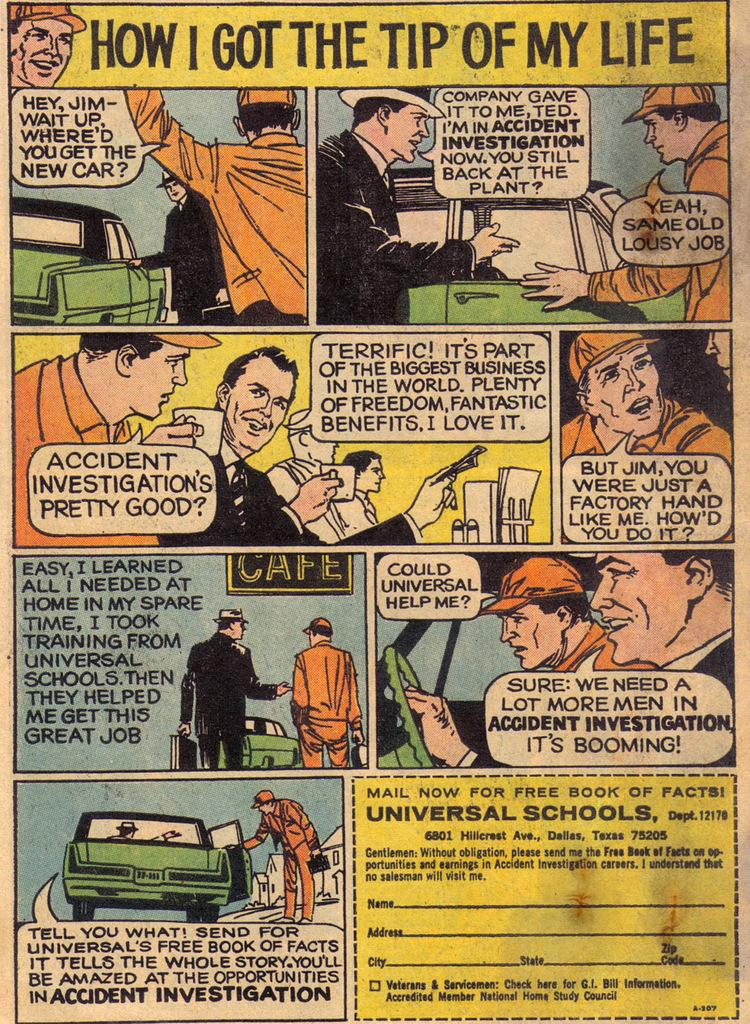What is the main subject of the paper in the image? The paper contains images of people, a car, and chairs. Are there any other elements on the paper besides the images? Yes, the paper contains text. What type of hole can be seen in the image? There is no hole present in the image; it features a paper with images and text. Can you tell me how many buckets are depicted on the paper? There are no buckets depicted on the paper; it features images of people, a car, and chairs, along with text. 